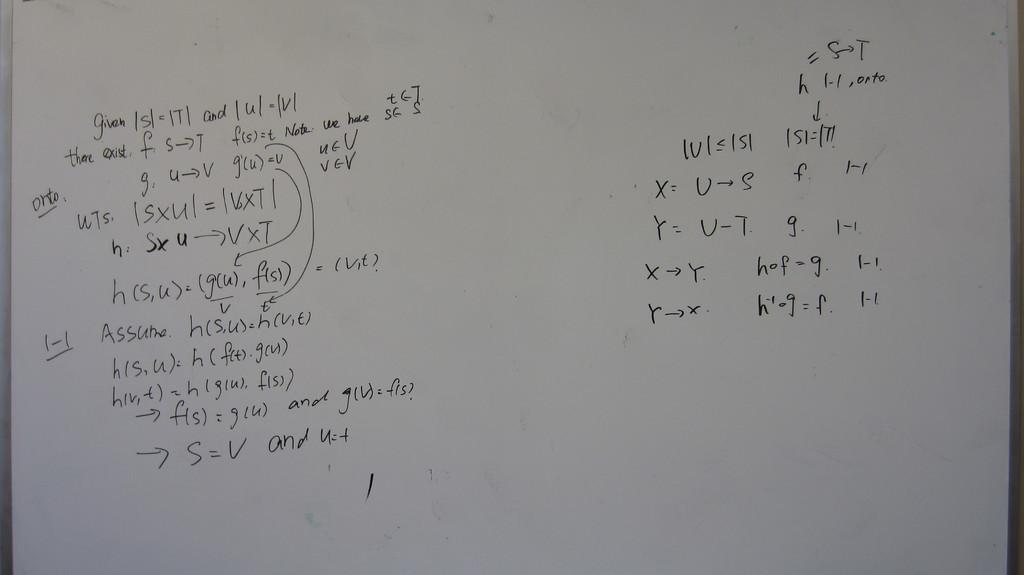<image>
Offer a succinct explanation of the picture presented. a white board close up with words "Given | s|" on it 